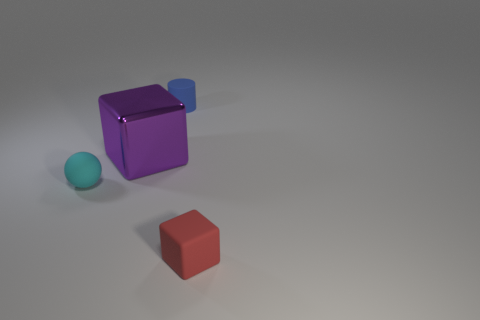Is there any other thing that has the same size as the purple thing?
Ensure brevity in your answer.  No. Are there any other things that have the same material as the purple object?
Provide a succinct answer. No. There is a red object that is the same material as the small ball; what is its shape?
Offer a terse response. Cube. What number of other objects are the same shape as the small blue matte object?
Offer a terse response. 0. Do the matte object that is behind the metallic object and the cyan object have the same size?
Your answer should be very brief. Yes. Is the number of rubber objects in front of the small cyan matte sphere greater than the number of red shiny blocks?
Your answer should be very brief. Yes. How many tiny cyan spheres are in front of the cyan matte ball to the left of the metal object?
Your answer should be compact. 0. Is the number of balls to the left of the red rubber object less than the number of rubber blocks?
Your answer should be very brief. No. Are there any matte objects in front of the cube behind the thing in front of the matte ball?
Provide a short and direct response. Yes. Do the large purple block and the cube that is right of the matte cylinder have the same material?
Your answer should be compact. No. 